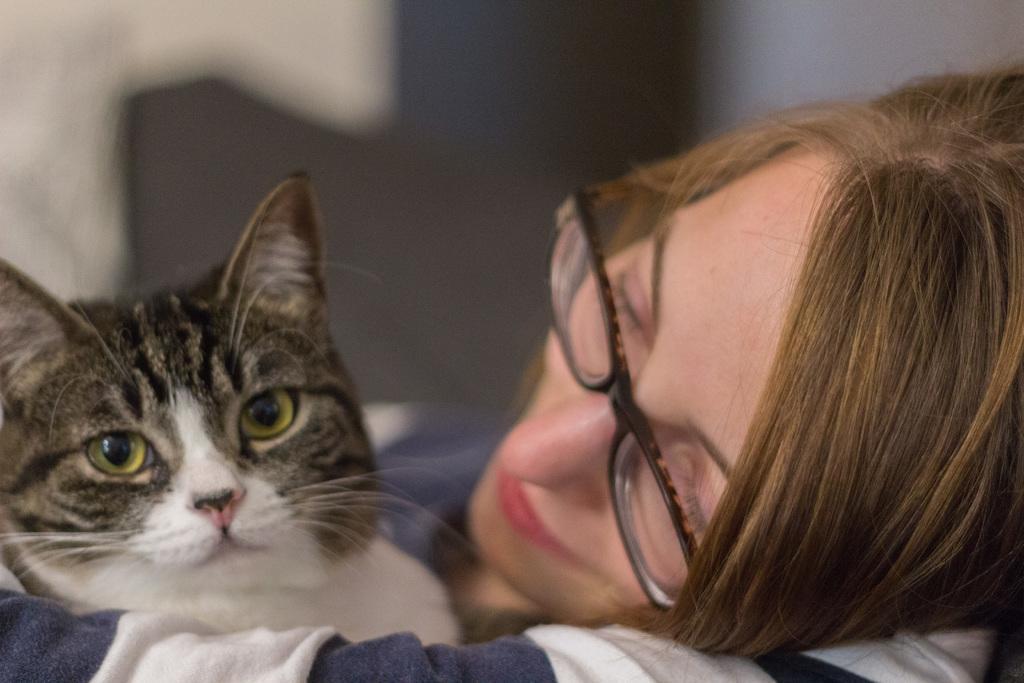Please provide a concise description of this image. In this I can see a woman holding a cat and she wore spectacles and I can see blurry background. 